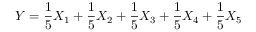<formula> <loc_0><loc_0><loc_500><loc_500>Y = \frac { 1 } { 5 } X _ { 1 } + \frac { 1 } { 5 } X _ { 2 } + \frac { 1 } { 5 } X _ { 3 } + \frac { 1 } { 5 } X _ { 4 } + \frac { 1 } { 5 } X _ { 5 }</formula> 